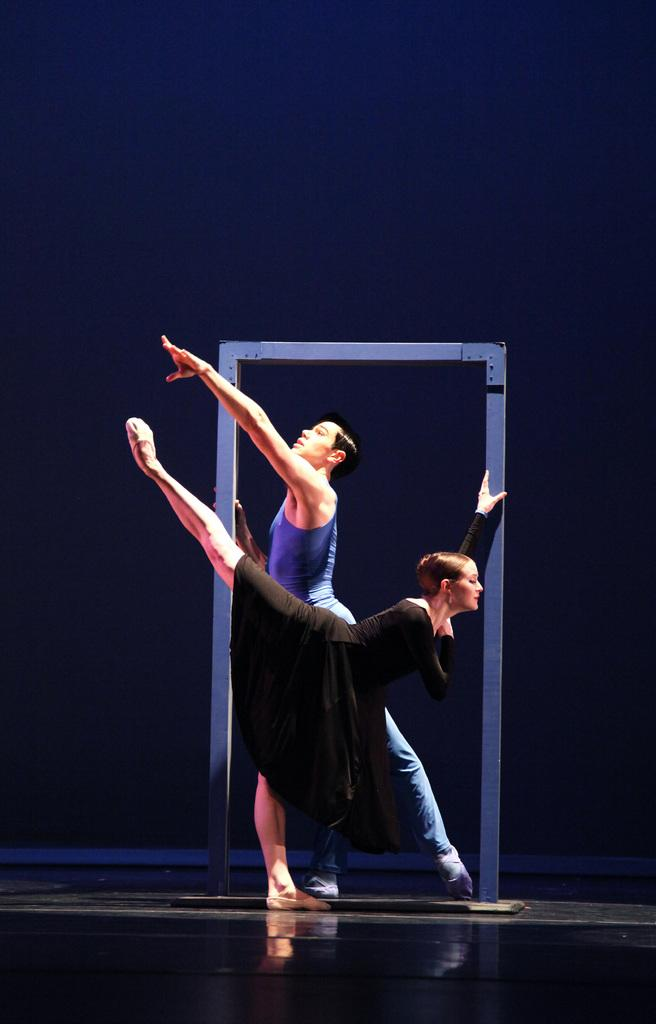How many people are in the image? There are two people in the image. What are the two people doing in the image? The two people are holding a prop and dancing. What can be observed about the background of the image? The background of the image is dark. What type of boats can be seen in the image? There are no boats present in the image. What word is being emphasized by the two people in the image? There is no specific word being emphasized in the image; the two people are holding a prop and dancing. 